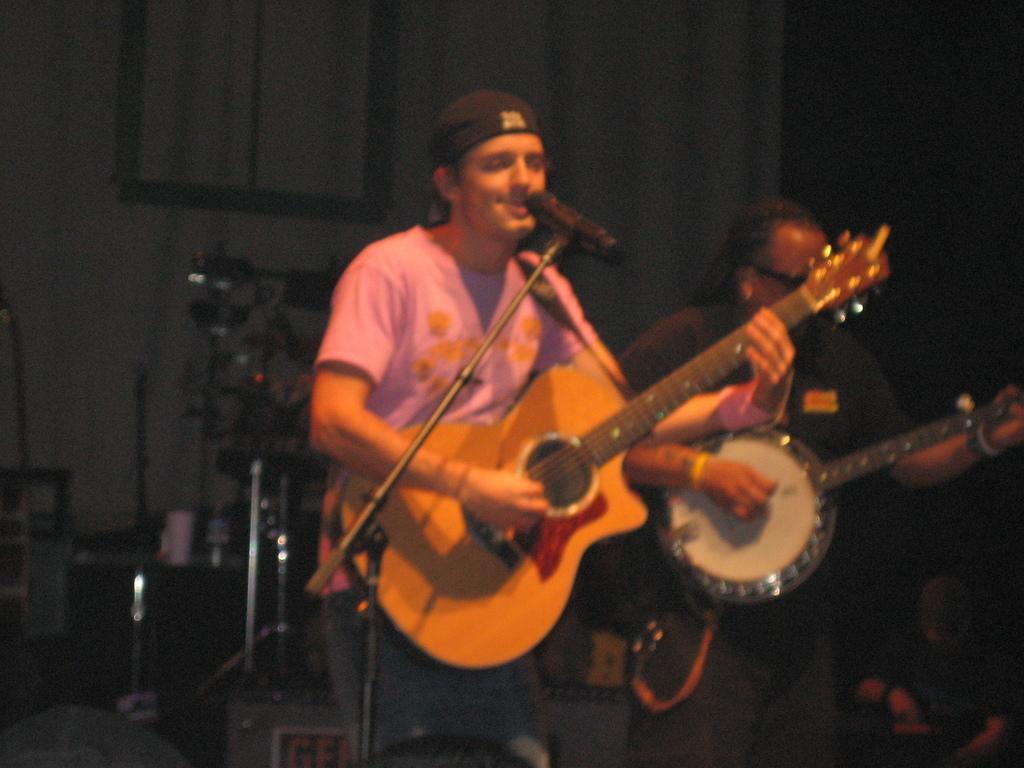How would you summarize this image in a sentence or two? In this image there are two persons standing and playing musical instruments. At the back there are speakers, in the front there are microphones. 